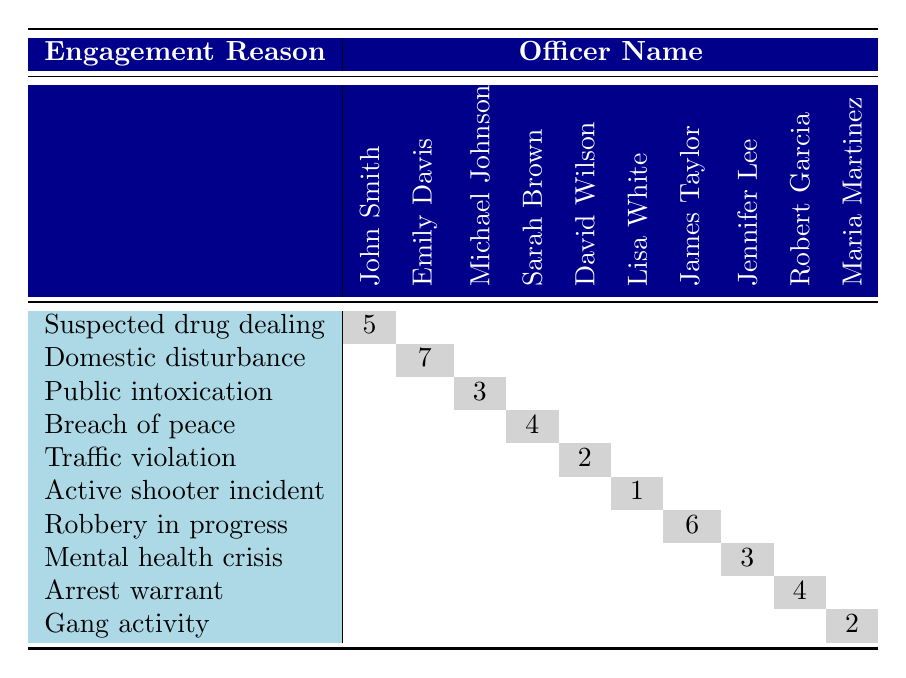What is the highest number of use of force incidents reported by a single officer? Looking at the table, I notice that the maximum incident count is in the row for "Domestic disturbance," where Officer Emily Davis has 7 incidents. I can scan through other officers and their counts, but they do not exceed this number.
Answer: 7 Which officer had the lowest number of incidents, and what was the reason for engagement? I review the table to find the lowest incident count, which is 1. The row for "Active shooter incident" indicates that Officer Lisa White was involved in this engagement. Hence, she had the fewest incidents in the table.
Answer: Officer Lisa White, Active shooter incident How many incidents were related to traffic violations and gang activity combined? To find the total, I look at the relevant rows: "Traffic violation" has 2 incidents, and "Gang activity" has 2 incidents. By adding them (2 + 2), I calculate the total as 4.
Answer: 4 Is there any officer who has reported more incidents for mental health crises than public intoxication? I check both rows: for "Mental health crisis," Officer Jennifer Lee reported 3 incidents, while for "Public intoxication," Officer Michael Johnson reported 3 as well. Thus, the counts are equal; therefore, no officer has reported more for mental health crises.
Answer: No What is the total number of use of force incidents reported across all officers? To find the total, I add up all the incident counts: 5 + 7 + 3 + 4 + 2 + 1 + 6 + 3 + 4 + 2 = 37. This calculation provides the overall total of incidents.
Answer: 37 How many different reasons for engagement are listed in the table? By counting the distinct categories in the first column, I find there are 10 unique reasons for engagement listed in the table.
Answer: 10 Which officer has the same number of incidents for both "Robbery in progress" and "Suspected drug dealing"? I examine the table: "Robbery in progress" has 6 incidents from Officer James Taylor, while "Suspected drug dealing" has 5 from Officer John Smith. Therefore, there are no officers with the same incident counts for these two reasons.
Answer: No What is the average number of incidents per officer based on the data provided? To find the average, I take the total number of incidents (37) and divide it by the number of officers (10). Thus, the average is 37 / 10 = 3.7.
Answer: 3.7 